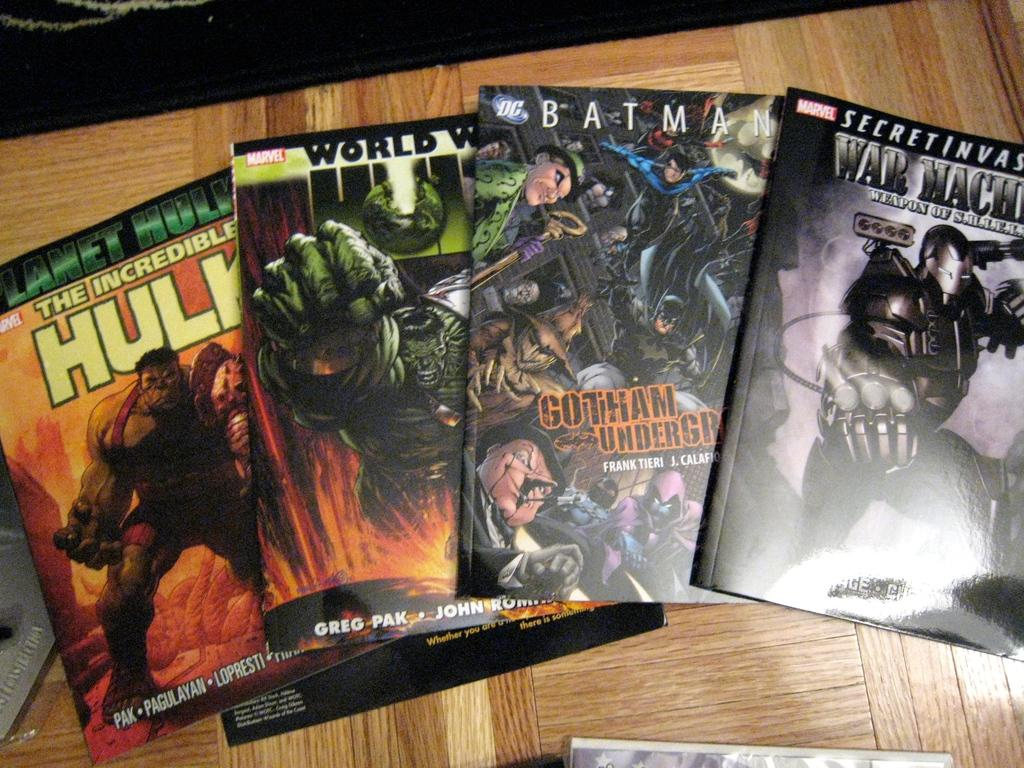<image>
Offer a succinct explanation of the picture presented. Some comic books include titles like Batman and the Incredible Hulk. 